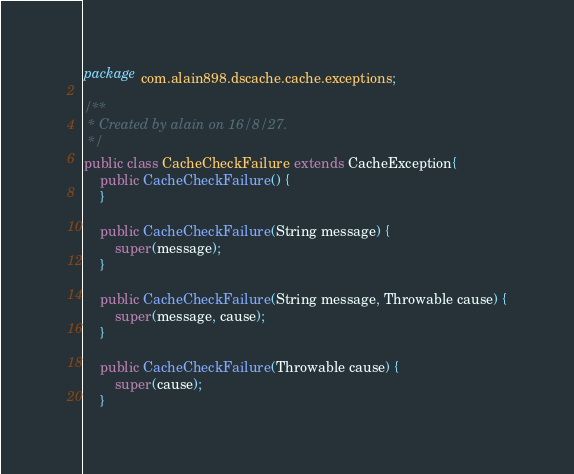Convert code to text. <code><loc_0><loc_0><loc_500><loc_500><_Java_>package com.alain898.dscache.cache.exceptions;

/**
 * Created by alain on 16/8/27.
 */
public class CacheCheckFailure extends CacheException{
    public CacheCheckFailure() {
    }

    public CacheCheckFailure(String message) {
        super(message);
    }

    public CacheCheckFailure(String message, Throwable cause) {
        super(message, cause);
    }

    public CacheCheckFailure(Throwable cause) {
        super(cause);
    }
</code> 